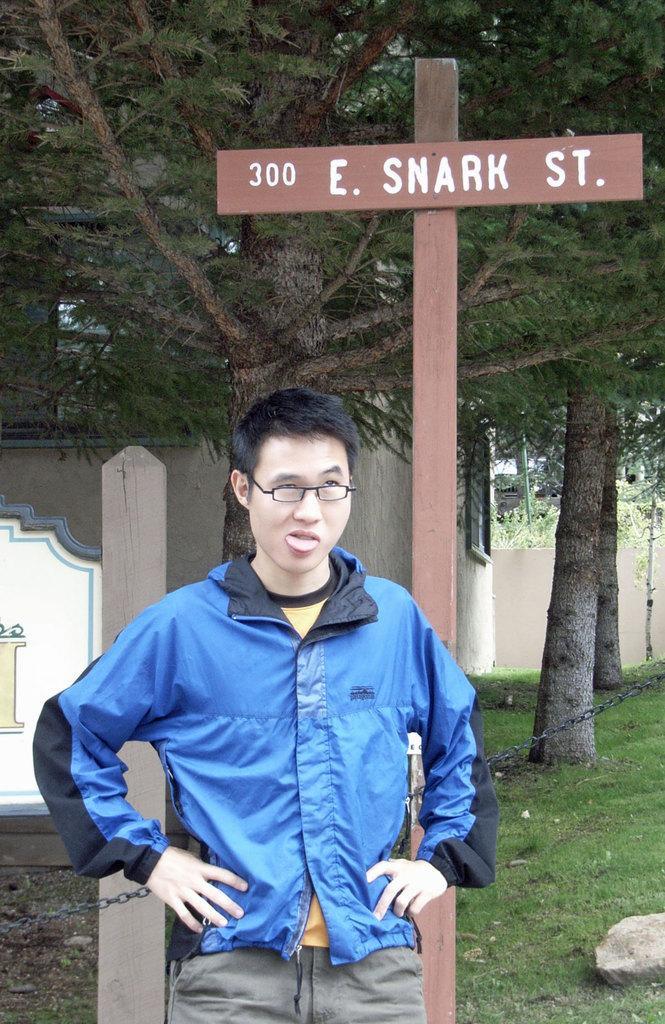In one or two sentences, can you explain what this image depicts? In this image there is a person standing, behind the person there is a chain fence, behind the fence there are trees, buildings, name sign board and a wooden stick, on the bottom right of the image there is a stone on the surface. 